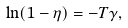<formula> <loc_0><loc_0><loc_500><loc_500>\ln ( 1 - \eta ) = - T \gamma ,</formula> 